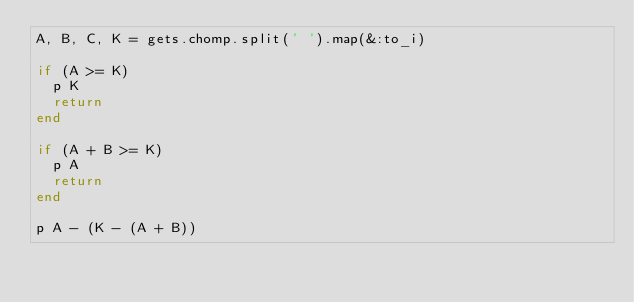Convert code to text. <code><loc_0><loc_0><loc_500><loc_500><_Ruby_>A, B, C, K = gets.chomp.split(' ').map(&:to_i)

if (A >= K)
  p K
  return
end

if (A + B >= K)
  p A
  return
end

p A - (K - (A + B))</code> 